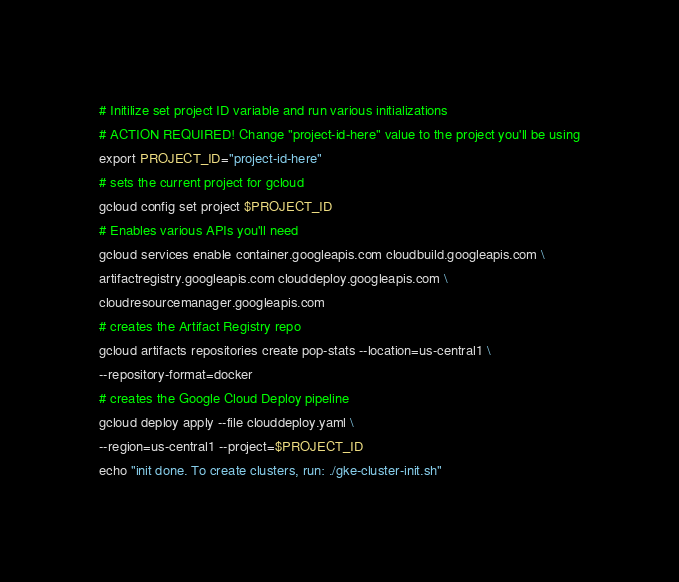Convert code to text. <code><loc_0><loc_0><loc_500><loc_500><_Bash_># Initilize set project ID variable and run various initializations
# ACTION REQUIRED! Change "project-id-here" value to the project you'll be using
export PROJECT_ID="project-id-here"
# sets the current project for gcloud
gcloud config set project $PROJECT_ID
# Enables various APIs you'll need
gcloud services enable container.googleapis.com cloudbuild.googleapis.com \
artifactregistry.googleapis.com clouddeploy.googleapis.com \
cloudresourcemanager.googleapis.com
# creates the Artifact Registry repo
gcloud artifacts repositories create pop-stats --location=us-central1 \
--repository-format=docker
# creates the Google Cloud Deploy pipeline
gcloud deploy apply --file clouddeploy.yaml \
--region=us-central1 --project=$PROJECT_ID
echo "init done. To create clusters, run: ./gke-cluster-init.sh"
</code> 